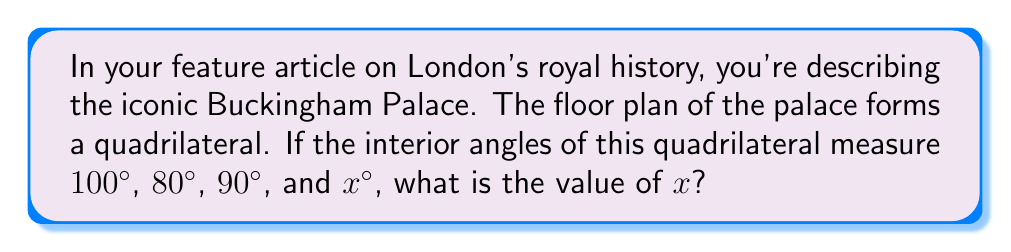Can you answer this question? To solve this problem, we'll use the property of interior angles in a quadrilateral:

1) In any quadrilateral, the sum of interior angles is always 360°.

2) We can express this as an equation:
   $$100° + 80° + 90° + x° = 360°$$

3) Simplify the left side of the equation:
   $$270° + x° = 360°$$

4) Subtract 270° from both sides:
   $$x° = 360° - 270°$$

5) Simplify:
   $$x° = 90°$$

Therefore, the fourth angle of the quadrilateral floor plan of Buckingham Palace measures 90°.
Answer: $x = 90°$ 